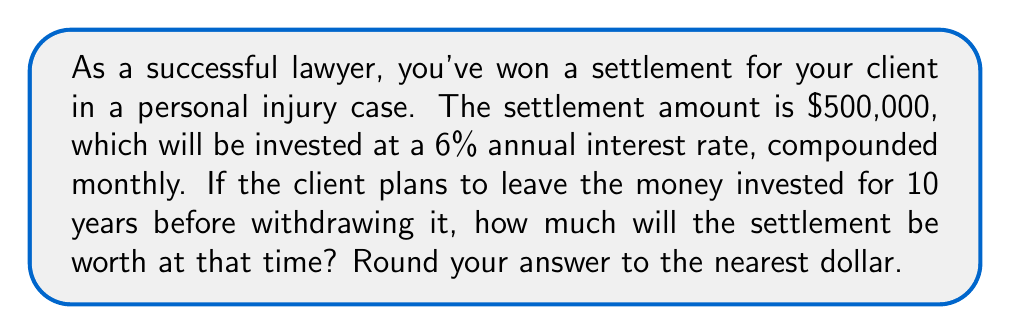Help me with this question. To solve this problem, we'll use the compound interest formula:

$$A = P(1 + \frac{r}{n})^{nt}$$

Where:
$A$ = final amount
$P$ = principal (initial investment)
$r$ = annual interest rate (in decimal form)
$n$ = number of times interest is compounded per year
$t$ = number of years

Given:
$P = \$500,000$
$r = 6\% = 0.06$
$n = 12$ (compounded monthly)
$t = 10$ years

Let's substitute these values into the formula:

$$A = 500,000(1 + \frac{0.06}{12})^{12 \cdot 10}$$

$$A = 500,000(1 + 0.005)^{120}$$

$$A = 500,000(1.005)^{120}$$

Using a calculator or computer to evaluate this expression:

$$A = 500,000 \cdot 1.8194097$$

$$A = 909,704.85$$

Rounding to the nearest dollar:

$$A = \$909,705$$
Answer: $909,705 